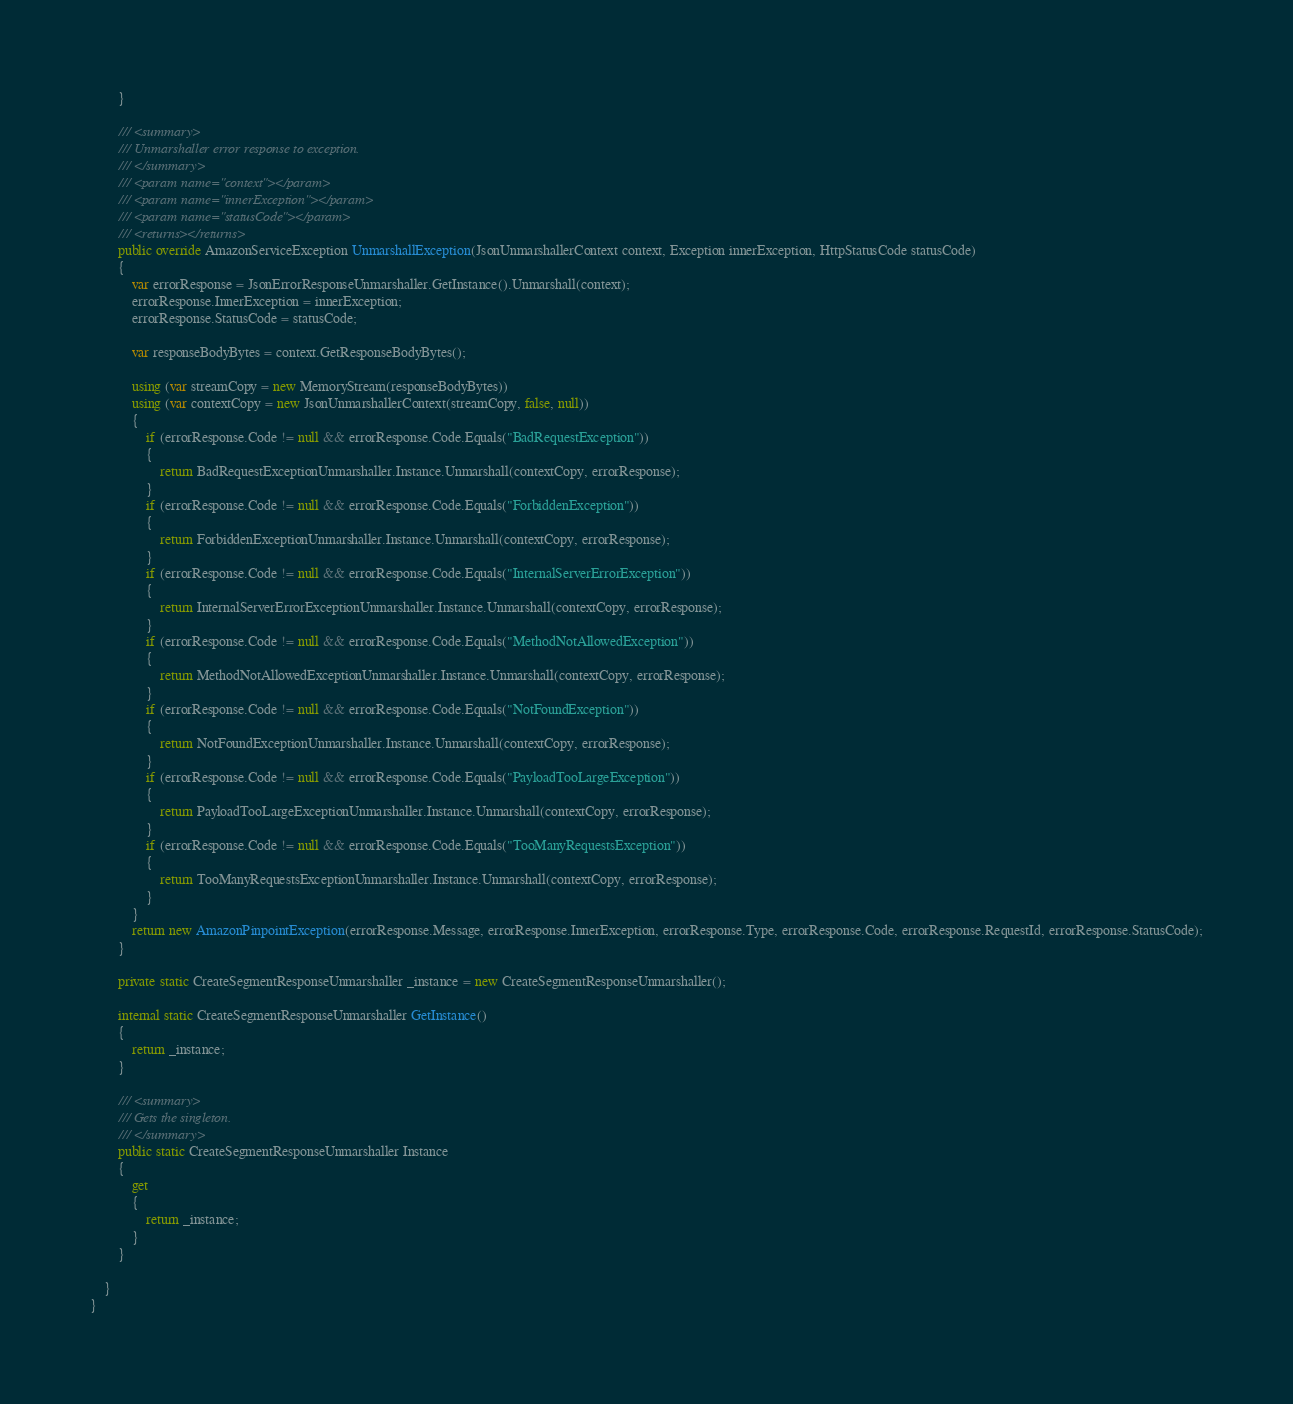<code> <loc_0><loc_0><loc_500><loc_500><_C#_>        }

        /// <summary>
        /// Unmarshaller error response to exception.
        /// </summary>  
        /// <param name="context"></param>
        /// <param name="innerException"></param>
        /// <param name="statusCode"></param>
        /// <returns></returns>
        public override AmazonServiceException UnmarshallException(JsonUnmarshallerContext context, Exception innerException, HttpStatusCode statusCode)
        {
            var errorResponse = JsonErrorResponseUnmarshaller.GetInstance().Unmarshall(context);
            errorResponse.InnerException = innerException;
            errorResponse.StatusCode = statusCode;

            var responseBodyBytes = context.GetResponseBodyBytes();

            using (var streamCopy = new MemoryStream(responseBodyBytes))
            using (var contextCopy = new JsonUnmarshallerContext(streamCopy, false, null))
            {
                if (errorResponse.Code != null && errorResponse.Code.Equals("BadRequestException"))
                {
                    return BadRequestExceptionUnmarshaller.Instance.Unmarshall(contextCopy, errorResponse);
                }
                if (errorResponse.Code != null && errorResponse.Code.Equals("ForbiddenException"))
                {
                    return ForbiddenExceptionUnmarshaller.Instance.Unmarshall(contextCopy, errorResponse);
                }
                if (errorResponse.Code != null && errorResponse.Code.Equals("InternalServerErrorException"))
                {
                    return InternalServerErrorExceptionUnmarshaller.Instance.Unmarshall(contextCopy, errorResponse);
                }
                if (errorResponse.Code != null && errorResponse.Code.Equals("MethodNotAllowedException"))
                {
                    return MethodNotAllowedExceptionUnmarshaller.Instance.Unmarshall(contextCopy, errorResponse);
                }
                if (errorResponse.Code != null && errorResponse.Code.Equals("NotFoundException"))
                {
                    return NotFoundExceptionUnmarshaller.Instance.Unmarshall(contextCopy, errorResponse);
                }
                if (errorResponse.Code != null && errorResponse.Code.Equals("PayloadTooLargeException"))
                {
                    return PayloadTooLargeExceptionUnmarshaller.Instance.Unmarshall(contextCopy, errorResponse);
                }
                if (errorResponse.Code != null && errorResponse.Code.Equals("TooManyRequestsException"))
                {
                    return TooManyRequestsExceptionUnmarshaller.Instance.Unmarshall(contextCopy, errorResponse);
                }
            }
            return new AmazonPinpointException(errorResponse.Message, errorResponse.InnerException, errorResponse.Type, errorResponse.Code, errorResponse.RequestId, errorResponse.StatusCode);
        }

        private static CreateSegmentResponseUnmarshaller _instance = new CreateSegmentResponseUnmarshaller();        

        internal static CreateSegmentResponseUnmarshaller GetInstance()
        {
            return _instance;
        }

        /// <summary>
        /// Gets the singleton.
        /// </summary>  
        public static CreateSegmentResponseUnmarshaller Instance
        {
            get
            {
                return _instance;
            }
        }

    }
}</code> 